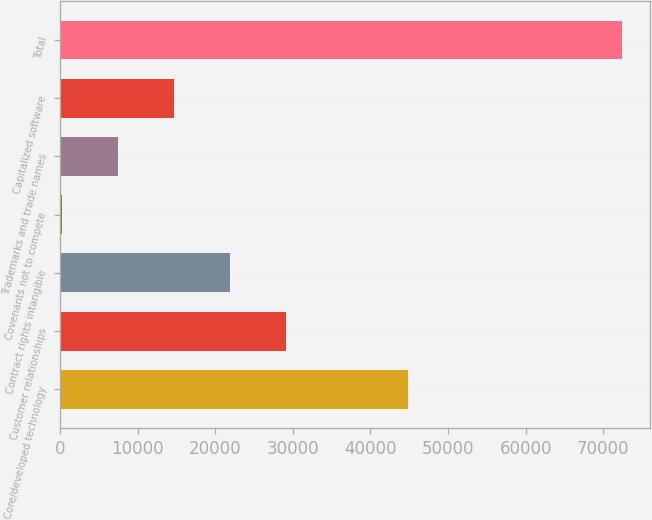Convert chart to OTSL. <chart><loc_0><loc_0><loc_500><loc_500><bar_chart><fcel>Core/developed technology<fcel>Customer relationships<fcel>Contract rights intangible<fcel>Covenants not to compete<fcel>Trademarks and trade names<fcel>Capitalized software<fcel>Total<nl><fcel>44869<fcel>29086.8<fcel>21870.6<fcel>222<fcel>7438.2<fcel>14654.4<fcel>72384<nl></chart> 